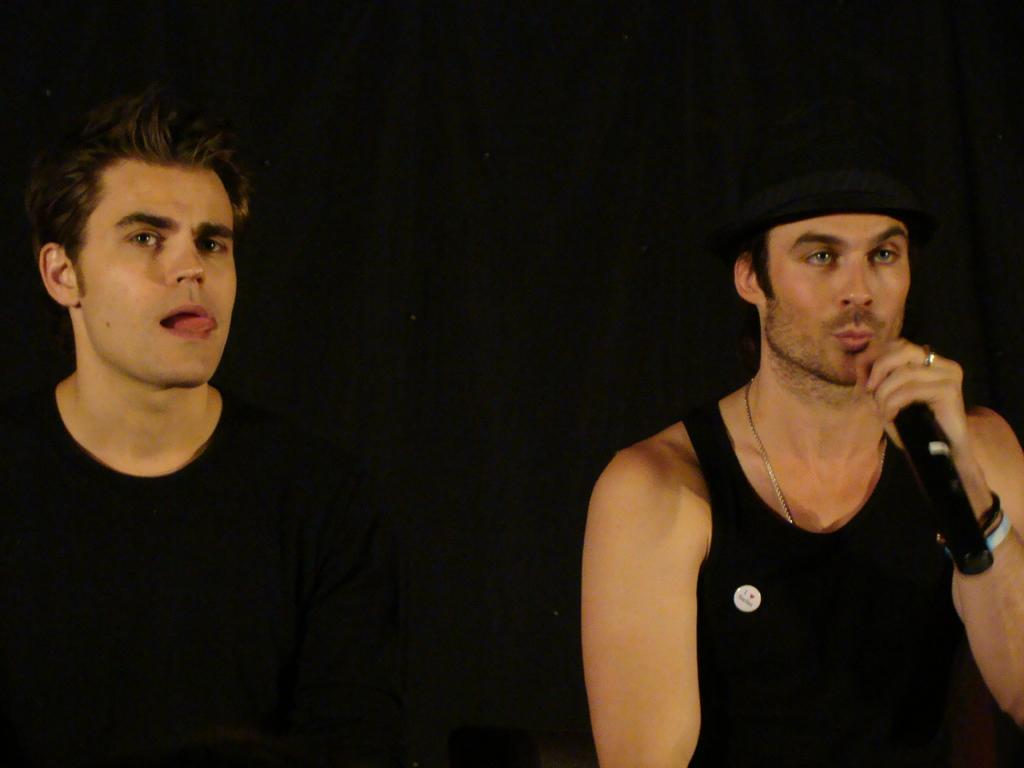What is the overall color scheme of the image? The background of the image is dark. What is the man in the image holding? The man is holding a microphone in his hand. What is the man doing with the microphone? The man is singing. Can you describe the other man in the image? There is another man at the left side of the image, and he has his tongue out of his mouth. How many horses can be seen running in the background of the image? There are no horses present in the image; the background is dark. Are there any dinosaurs visible in the image? No, there are no dinosaurs present in the image. 